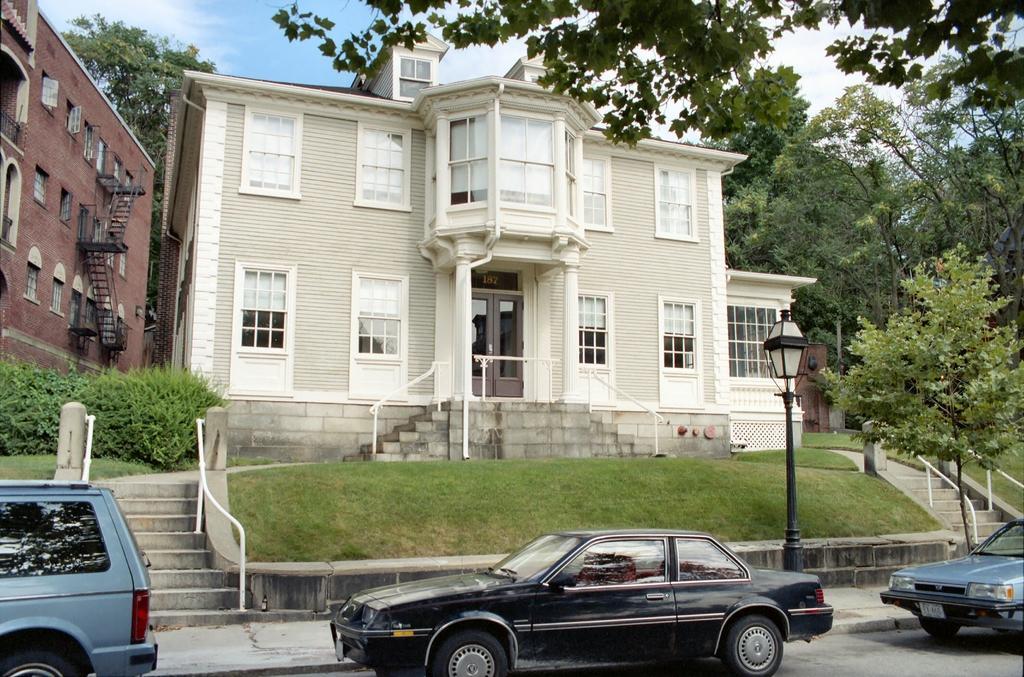Describe this image in one or two sentences. In this picture we can see cars in the front, there are stairs, grass, a pole, a light and plants in the middle, in the background there are buildings and trees, there is the sky at the top of the picture. 